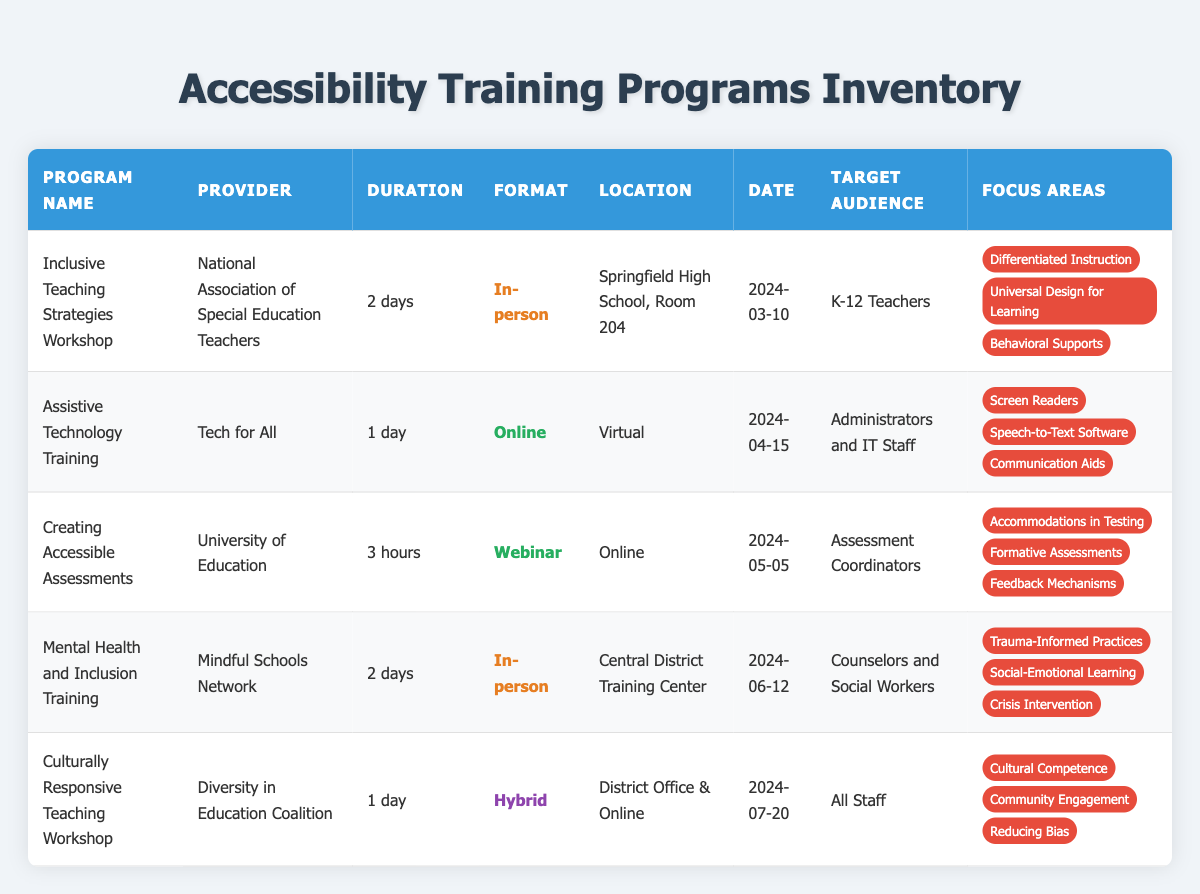What is the date of the "Inclusive Teaching Strategies Workshop"? The date can be found in the table under the "Date" column corresponding to the "Inclusive Teaching Strategies Workshop," which shows "2024-03-10."
Answer: 2024-03-10 Who is the provider of the "Assistive Technology Training"? The provider is listed in the "Provider" column for the "Assistive Technology Training," which is "Tech for All."
Answer: Tech for All How many days is the "Mental Health and Inclusion Training" program? The duration of the program can be found in the "Duration" column for "Mental Health and Inclusion Training," which states "2 days."
Answer: 2 days Is the "Creating Accessible Assessments" program offered in-person? The format for "Creating Accessible Assessments" listed in the "Format" column indicates "Webinar," which means it is not in-person.
Answer: No Which target audience is the "Culturally Responsive Teaching Workshop" aimed at? The target audience can be found in the "Target Audience" column for the "Culturally Responsive Teaching Workshop," which states "All Staff."
Answer: All Staff What is the total duration of the "Inclusive Teaching Strategies Workshop" and the "Mental Health and Inclusion Training" combined? The "Inclusive Teaching Strategies Workshop" lasts "2 days," and the "Mental Health and Inclusion Training" also lasts "2 days." Therefore, combining them gives a total of 4 days.
Answer: 4 days Which training program focuses on "Trauma-Informed Practices"? By checking the "Focus Areas" column for each program, "Trauma-Informed Practices" is listed under the "Mental Health and Inclusion Training."
Answer: Mental Health and Inclusion Training Are there any workshops specifically for K-12 Teachers? In the "Target Audience" column, "K-12 Teachers" is mentioned under the "Inclusive Teaching Strategies Workshop," confirming that there is a workshop aimed at them.
Answer: Yes What type of access do the "Assistive Technology Training" and "Creating Accessible Assessments" programs share? Both programs are noted in the "Format" column as "Online," which indicates they are accessible remotely.
Answer: Online 